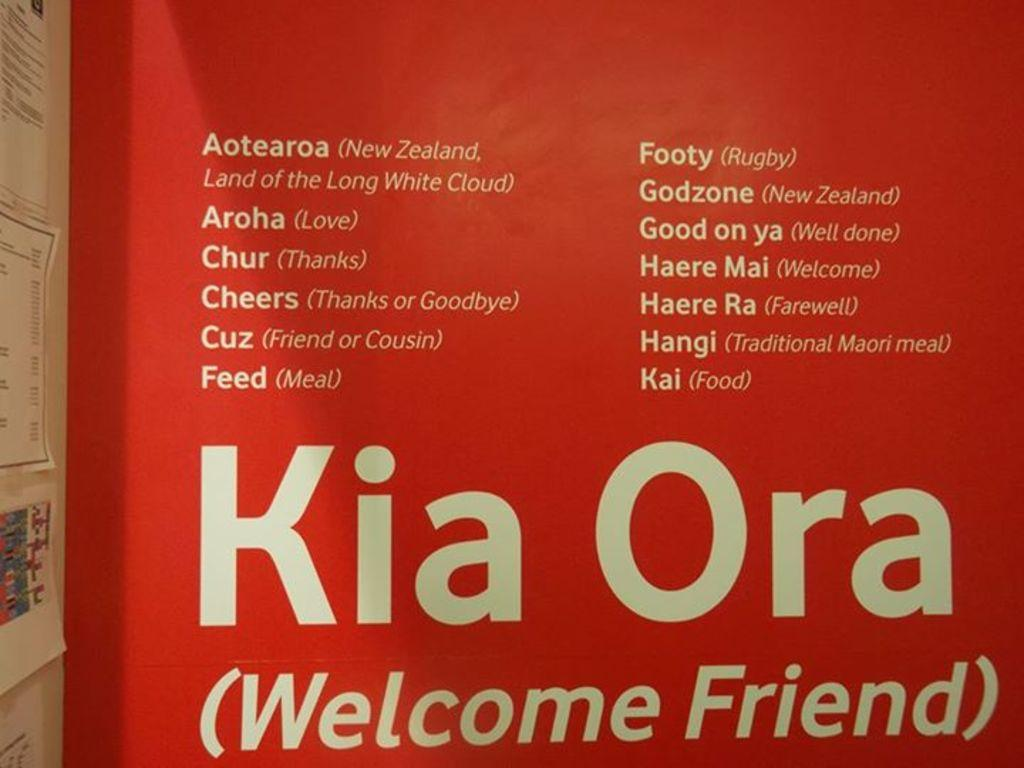<image>
Offer a succinct explanation of the picture presented. Welcome friend on a wall by a bulletin board 